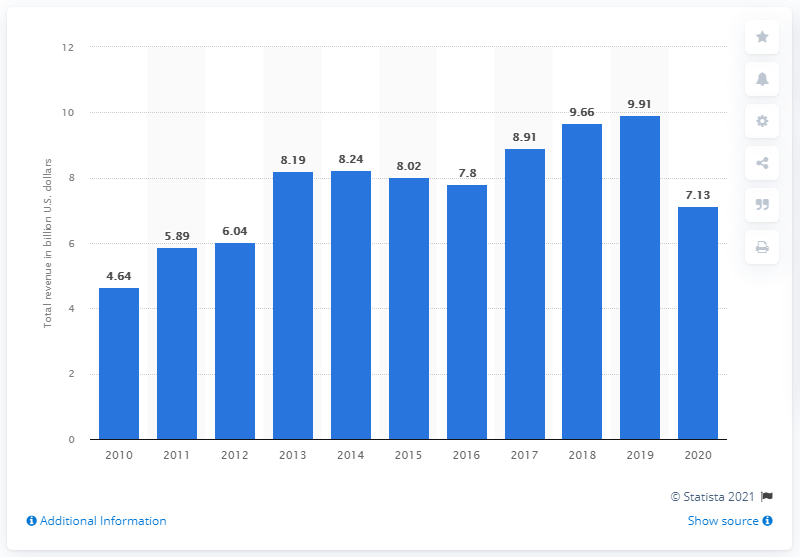Identify some key points in this picture. In 2020, PVH Corporation's global revenue was 7.13 billion dollars. 